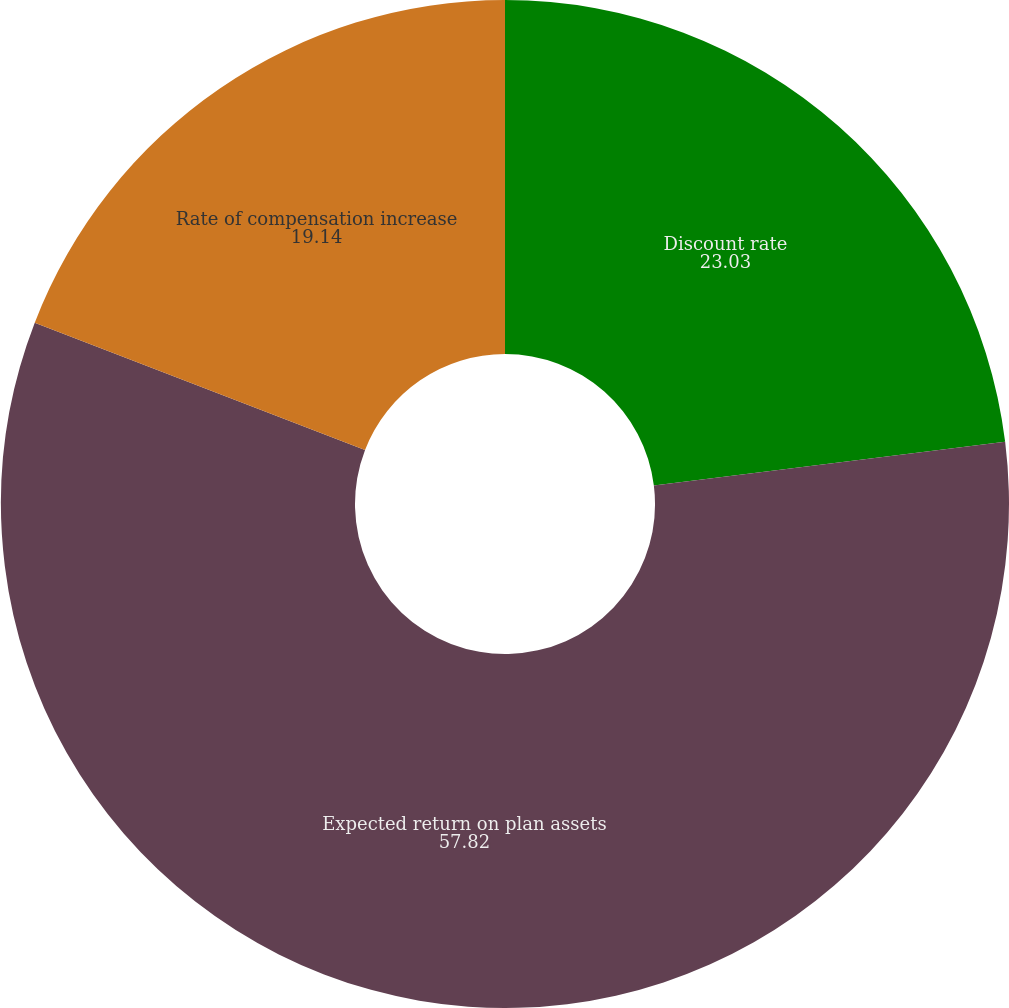<chart> <loc_0><loc_0><loc_500><loc_500><pie_chart><fcel>Discount rate<fcel>Expected return on plan assets<fcel>Rate of compensation increase<nl><fcel>23.03%<fcel>57.82%<fcel>19.14%<nl></chart> 